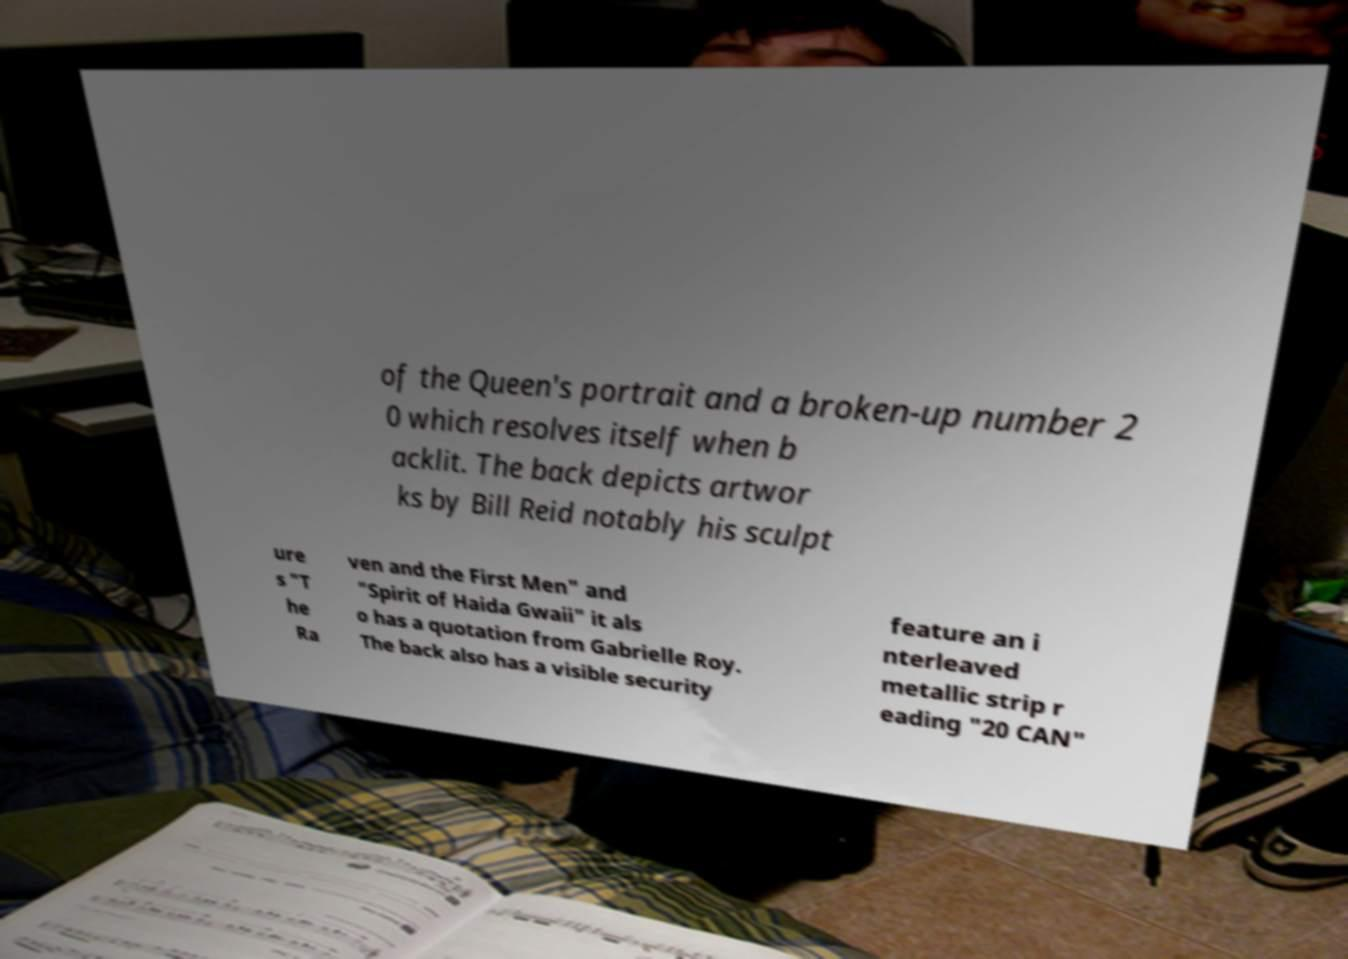Can you accurately transcribe the text from the provided image for me? of the Queen's portrait and a broken-up number 2 0 which resolves itself when b acklit. The back depicts artwor ks by Bill Reid notably his sculpt ure s "T he Ra ven and the First Men" and "Spirit of Haida Gwaii" it als o has a quotation from Gabrielle Roy. The back also has a visible security feature an i nterleaved metallic strip r eading "20 CAN" 